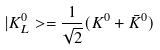Convert formula to latex. <formula><loc_0><loc_0><loc_500><loc_500>| K ^ { 0 } _ { L } > = \frac { 1 } { \sqrt { 2 } } ( K ^ { 0 } + \bar { K } ^ { 0 } )</formula> 